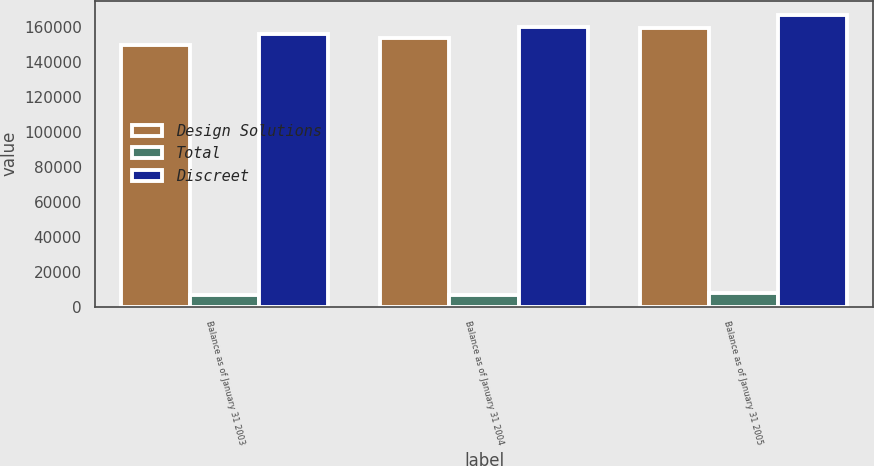Convert chart. <chart><loc_0><loc_0><loc_500><loc_500><stacked_bar_chart><ecel><fcel>Balance as of January 31 2003<fcel>Balance as of January 31 2004<fcel>Balance as of January 31 2005<nl><fcel>Design Solutions<fcel>149539<fcel>153688<fcel>159063<nl><fcel>Total<fcel>6406<fcel>6406<fcel>7565<nl><fcel>Discreet<fcel>155945<fcel>160094<fcel>166628<nl></chart> 